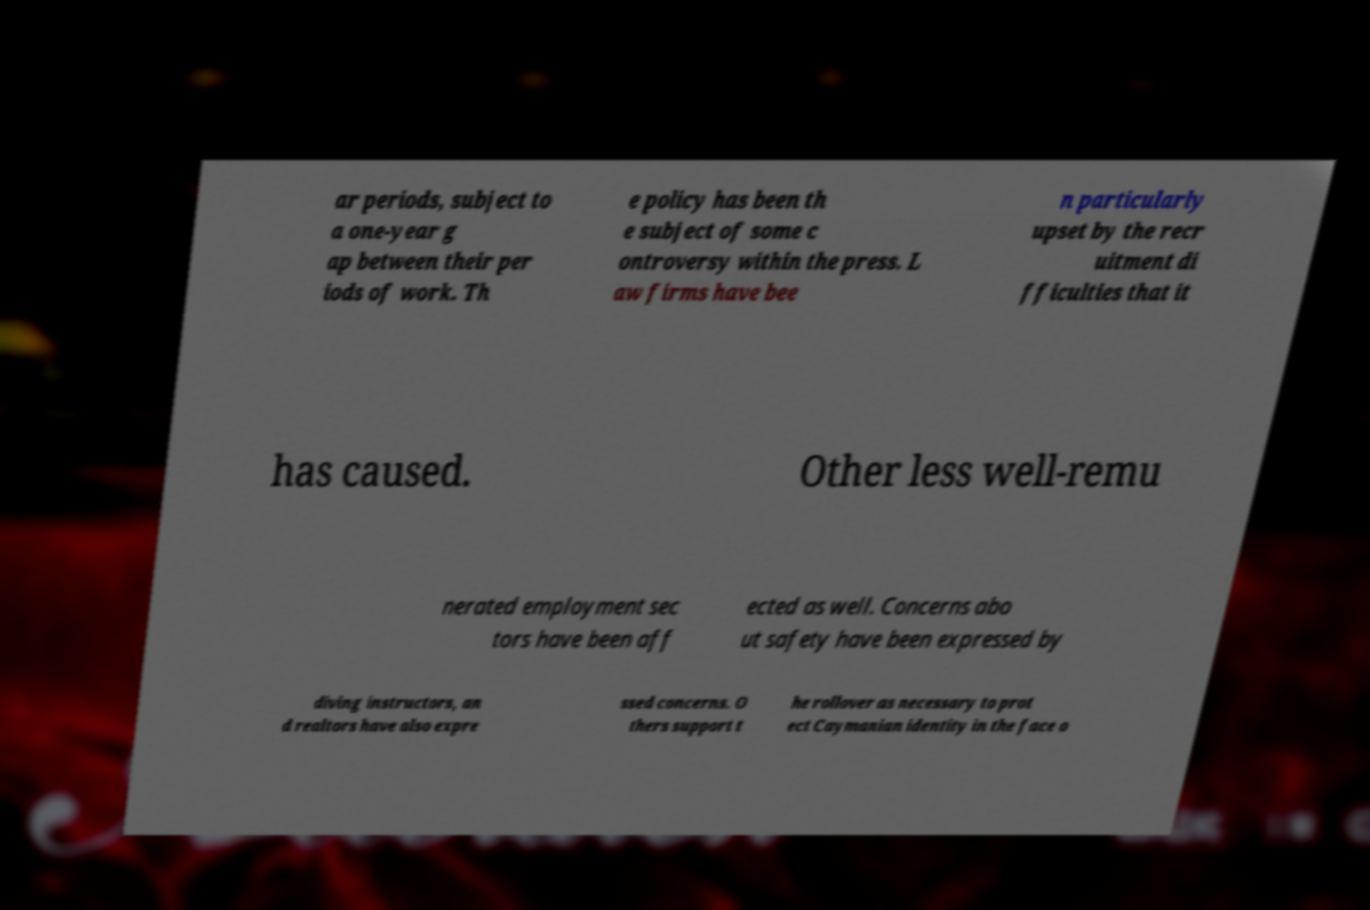Can you accurately transcribe the text from the provided image for me? ar periods, subject to a one-year g ap between their per iods of work. Th e policy has been th e subject of some c ontroversy within the press. L aw firms have bee n particularly upset by the recr uitment di fficulties that it has caused. Other less well-remu nerated employment sec tors have been aff ected as well. Concerns abo ut safety have been expressed by diving instructors, an d realtors have also expre ssed concerns. O thers support t he rollover as necessary to prot ect Caymanian identity in the face o 